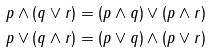Convert formula to latex. <formula><loc_0><loc_0><loc_500><loc_500>p & \wedge ( q \vee r ) = ( p \wedge q ) \vee ( p \wedge r ) \\ p & \vee ( q \wedge r ) = ( p \vee q ) \wedge ( p \vee r )</formula> 